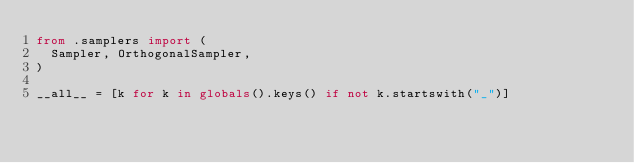Convert code to text. <code><loc_0><loc_0><loc_500><loc_500><_Python_>from .samplers import (
  Sampler, OrthogonalSampler,
)

__all__ = [k for k in globals().keys() if not k.startswith("_")]

</code> 